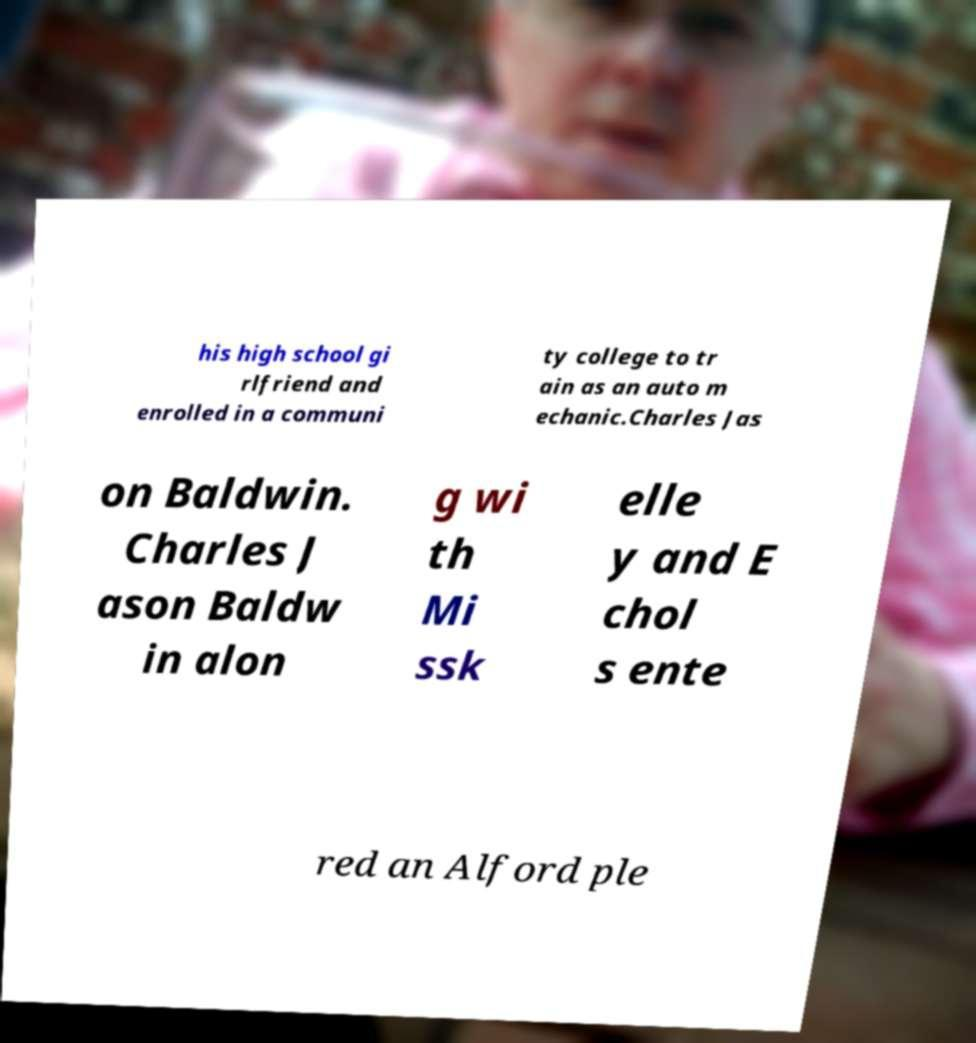Can you read and provide the text displayed in the image?This photo seems to have some interesting text. Can you extract and type it out for me? his high school gi rlfriend and enrolled in a communi ty college to tr ain as an auto m echanic.Charles Jas on Baldwin. Charles J ason Baldw in alon g wi th Mi ssk elle y and E chol s ente red an Alford ple 